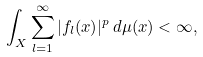Convert formula to latex. <formula><loc_0><loc_0><loc_500><loc_500>\int _ { X } \sum _ { l = 1 } ^ { \infty } | f _ { l } ( x ) | ^ { p } \, d \mu ( x ) < \infty ,</formula> 